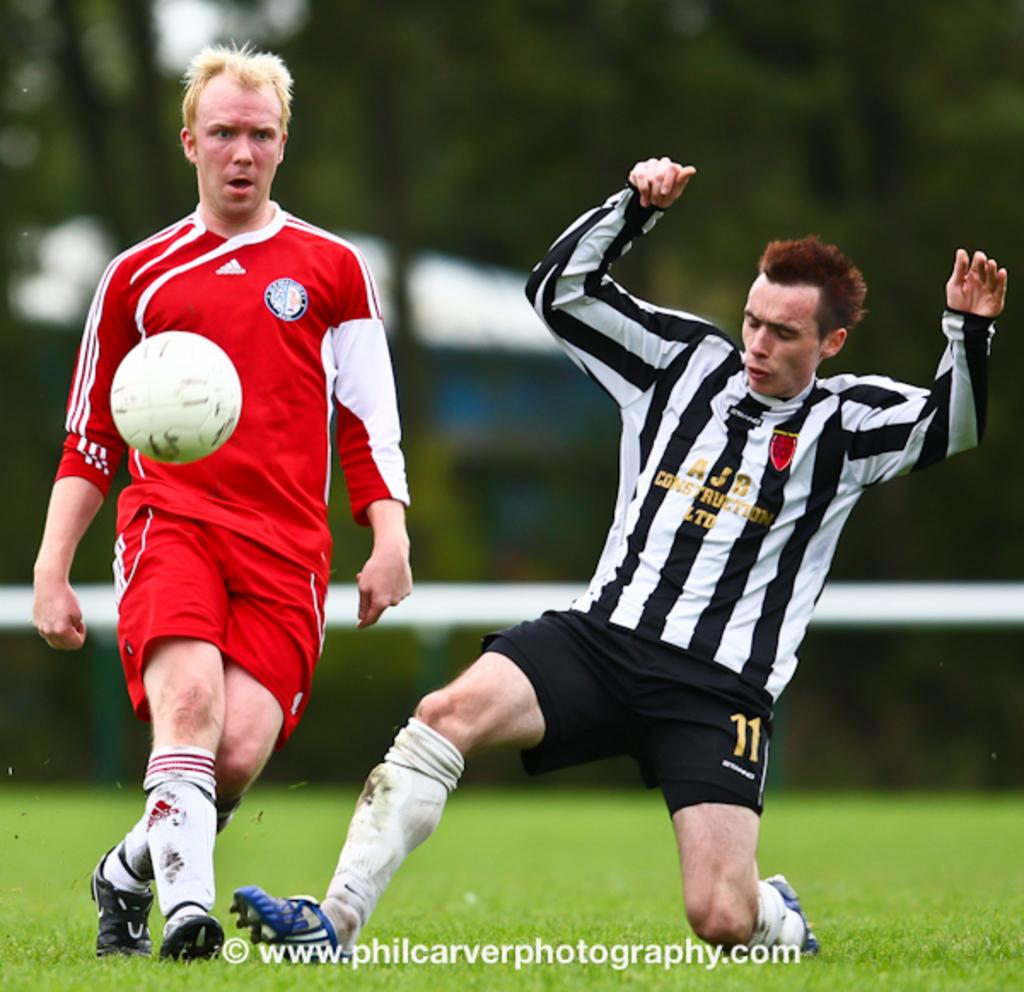What number is on the black shorts?
Keep it short and to the point. 11. 